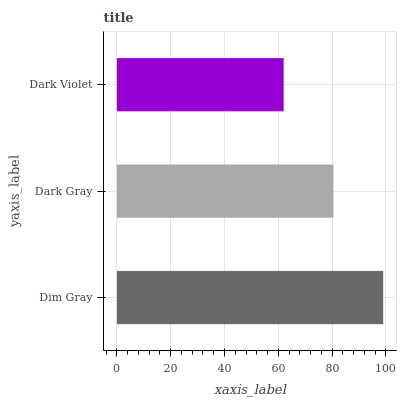Is Dark Violet the minimum?
Answer yes or no. Yes. Is Dim Gray the maximum?
Answer yes or no. Yes. Is Dark Gray the minimum?
Answer yes or no. No. Is Dark Gray the maximum?
Answer yes or no. No. Is Dim Gray greater than Dark Gray?
Answer yes or no. Yes. Is Dark Gray less than Dim Gray?
Answer yes or no. Yes. Is Dark Gray greater than Dim Gray?
Answer yes or no. No. Is Dim Gray less than Dark Gray?
Answer yes or no. No. Is Dark Gray the high median?
Answer yes or no. Yes. Is Dark Gray the low median?
Answer yes or no. Yes. Is Dim Gray the high median?
Answer yes or no. No. Is Dark Violet the low median?
Answer yes or no. No. 